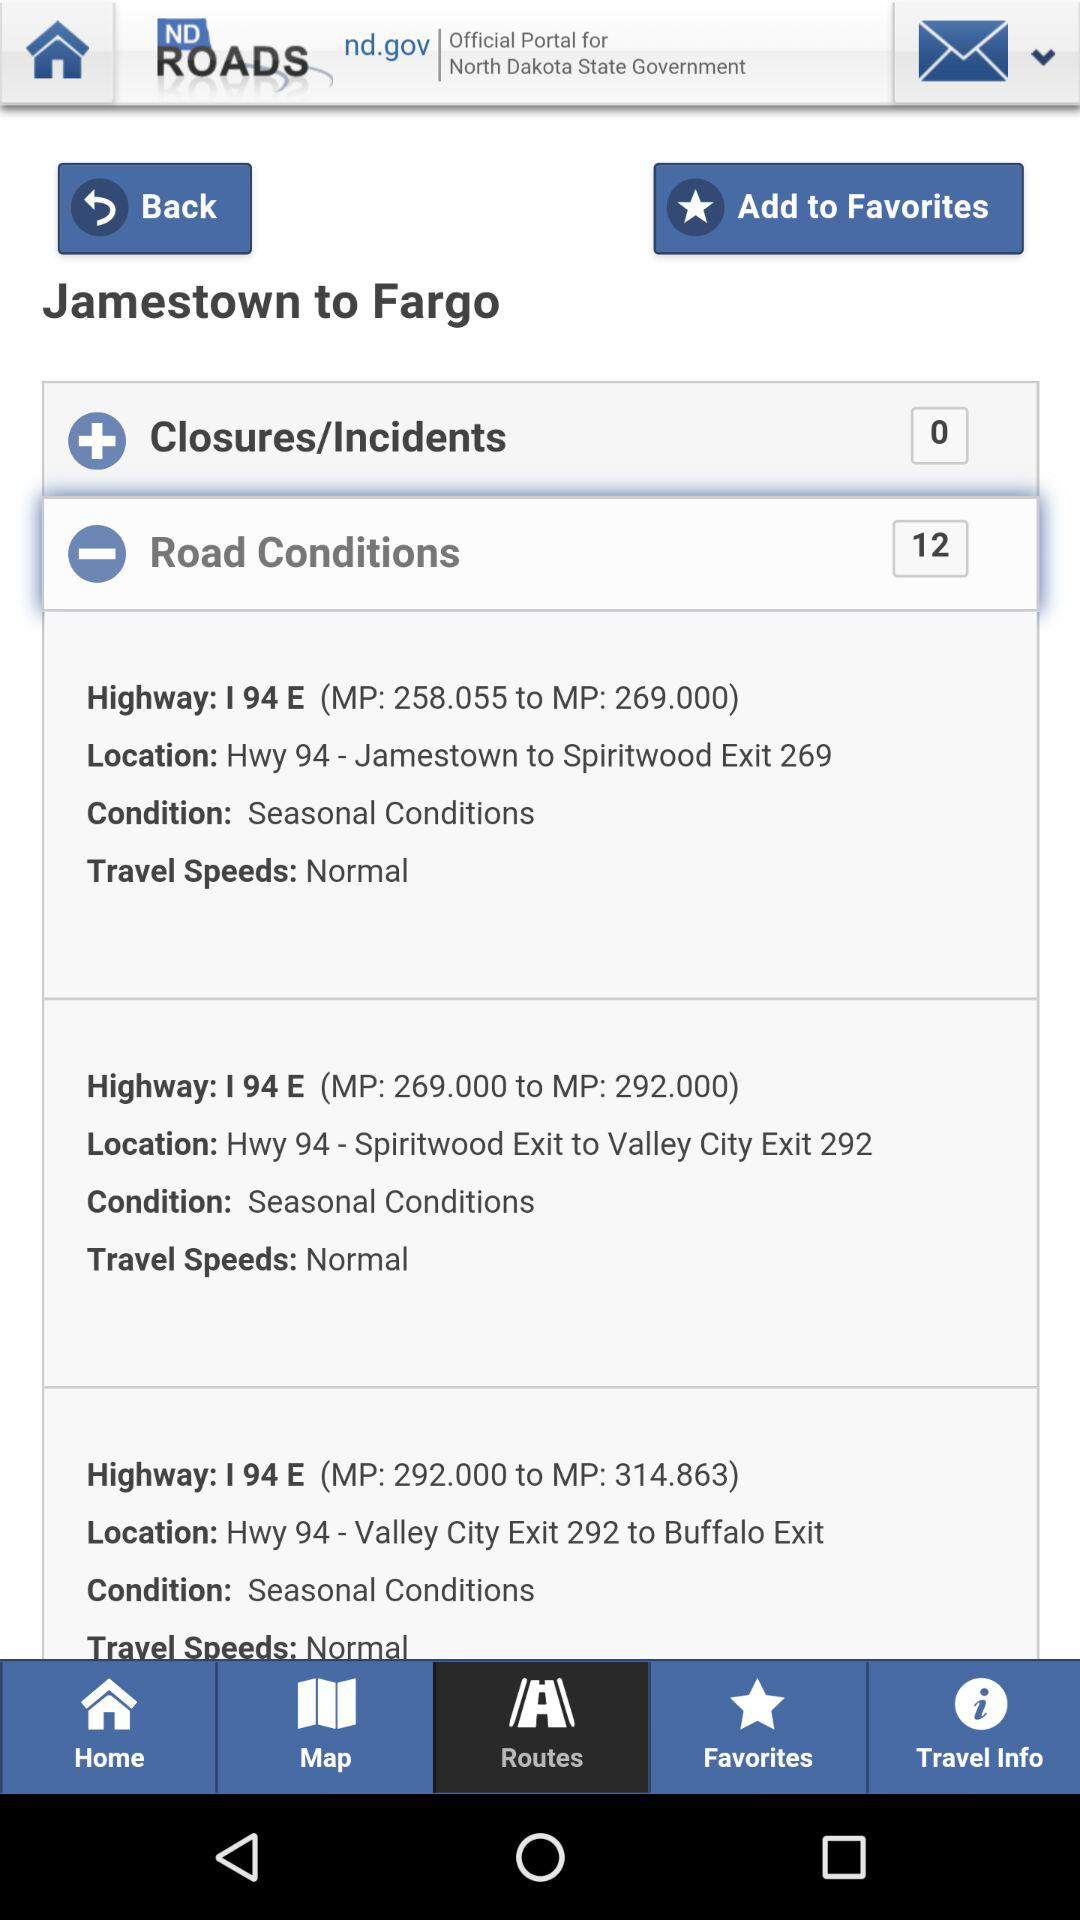How many closures/incidents in total are there? There are zero closures/incidents. 